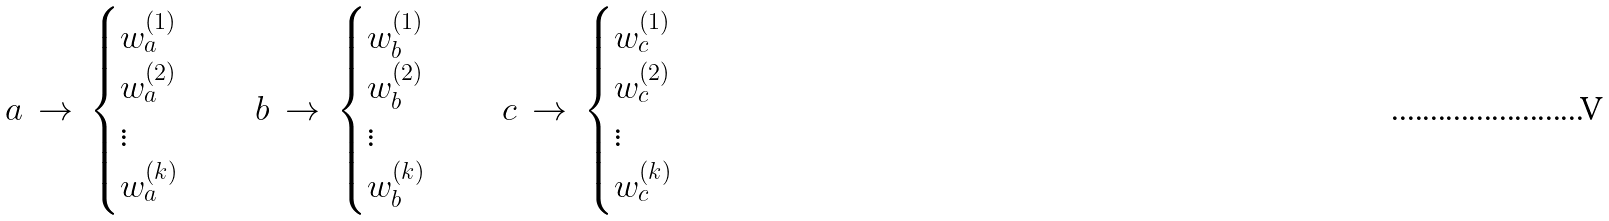Convert formula to latex. <formula><loc_0><loc_0><loc_500><loc_500>a \, \rightarrow \, \begin{cases} w _ { a } ^ { ( 1 ) } \\ w _ { a } ^ { ( 2 ) } \\ \vdots \\ w _ { a } ^ { ( k ) } \end{cases} \quad b \, \rightarrow \, \begin{cases} w _ { b } ^ { ( 1 ) } \\ w _ { b } ^ { ( 2 ) } \\ \vdots \\ w _ { b } ^ { ( k ) } \end{cases} \quad c \, \rightarrow \, \begin{cases} w _ { c } ^ { ( 1 ) } \\ w _ { c } ^ { ( 2 ) } \\ \vdots \\ w _ { c } ^ { ( k ) } \end{cases}</formula> 